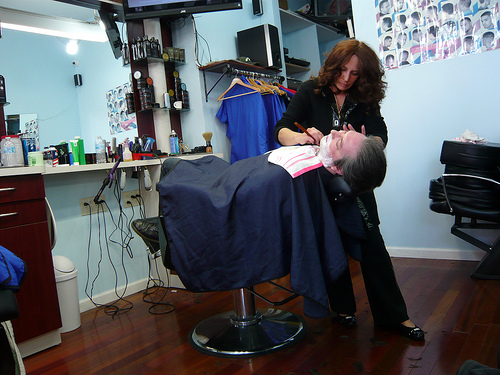<image>
Is the shirt on the hanger? Yes. Looking at the image, I can see the shirt is positioned on top of the hanger, with the hanger providing support. Is there a man on the floor? No. The man is not positioned on the floor. They may be near each other, but the man is not supported by or resting on top of the floor. Where is the cloth in relation to the woman? Is it on the woman? No. The cloth is not positioned on the woman. They may be near each other, but the cloth is not supported by or resting on top of the woman. Is there a man behind the woman? No. The man is not behind the woman. From this viewpoint, the man appears to be positioned elsewhere in the scene. 